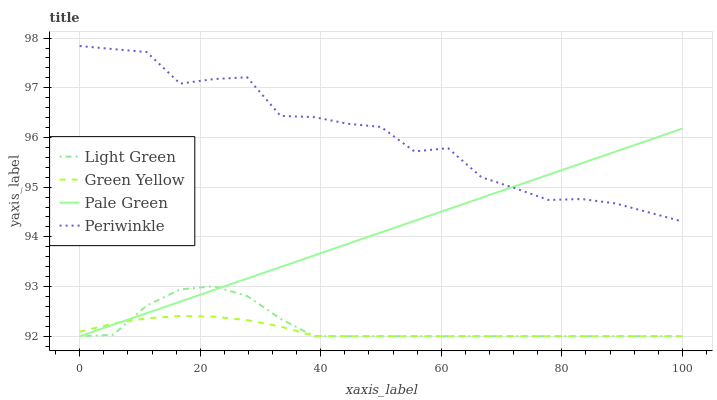Does Green Yellow have the minimum area under the curve?
Answer yes or no. Yes. Does Periwinkle have the maximum area under the curve?
Answer yes or no. Yes. Does Periwinkle have the minimum area under the curve?
Answer yes or no. No. Does Green Yellow have the maximum area under the curve?
Answer yes or no. No. Is Pale Green the smoothest?
Answer yes or no. Yes. Is Periwinkle the roughest?
Answer yes or no. Yes. Is Green Yellow the smoothest?
Answer yes or no. No. Is Green Yellow the roughest?
Answer yes or no. No. Does Periwinkle have the lowest value?
Answer yes or no. No. Does Periwinkle have the highest value?
Answer yes or no. Yes. Does Green Yellow have the highest value?
Answer yes or no. No. Is Green Yellow less than Periwinkle?
Answer yes or no. Yes. Is Periwinkle greater than Light Green?
Answer yes or no. Yes. Does Periwinkle intersect Pale Green?
Answer yes or no. Yes. Is Periwinkle less than Pale Green?
Answer yes or no. No. Is Periwinkle greater than Pale Green?
Answer yes or no. No. Does Green Yellow intersect Periwinkle?
Answer yes or no. No. 